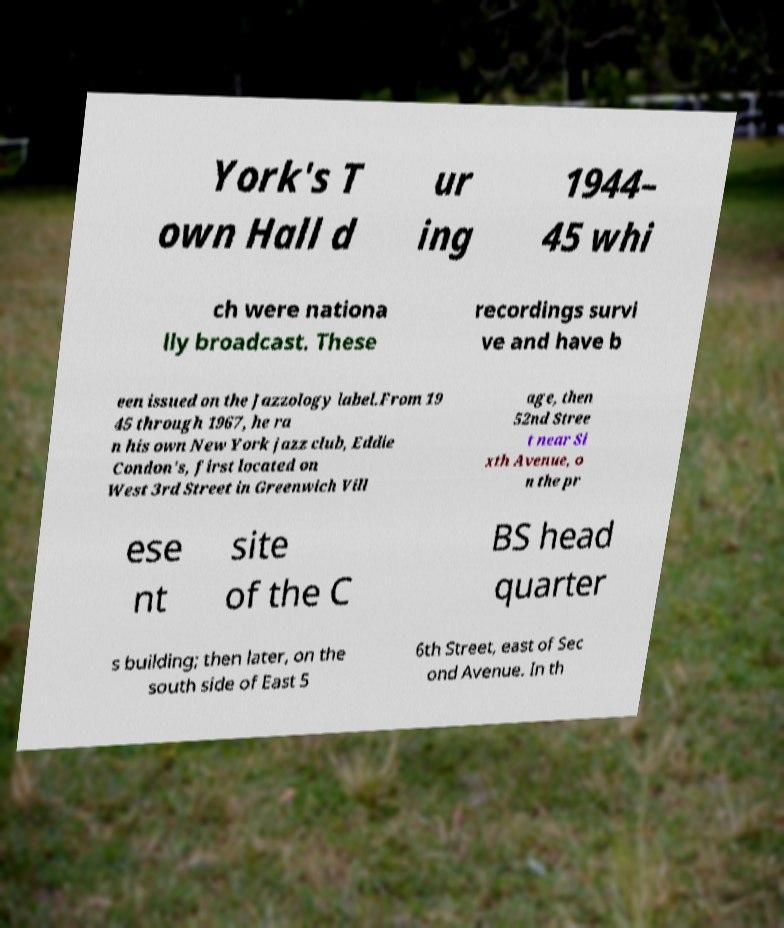Could you assist in decoding the text presented in this image and type it out clearly? York's T own Hall d ur ing 1944– 45 whi ch were nationa lly broadcast. These recordings survi ve and have b een issued on the Jazzology label.From 19 45 through 1967, he ra n his own New York jazz club, Eddie Condon's, first located on West 3rd Street in Greenwich Vill age, then 52nd Stree t near Si xth Avenue, o n the pr ese nt site of the C BS head quarter s building; then later, on the south side of East 5 6th Street, east of Sec ond Avenue. In th 